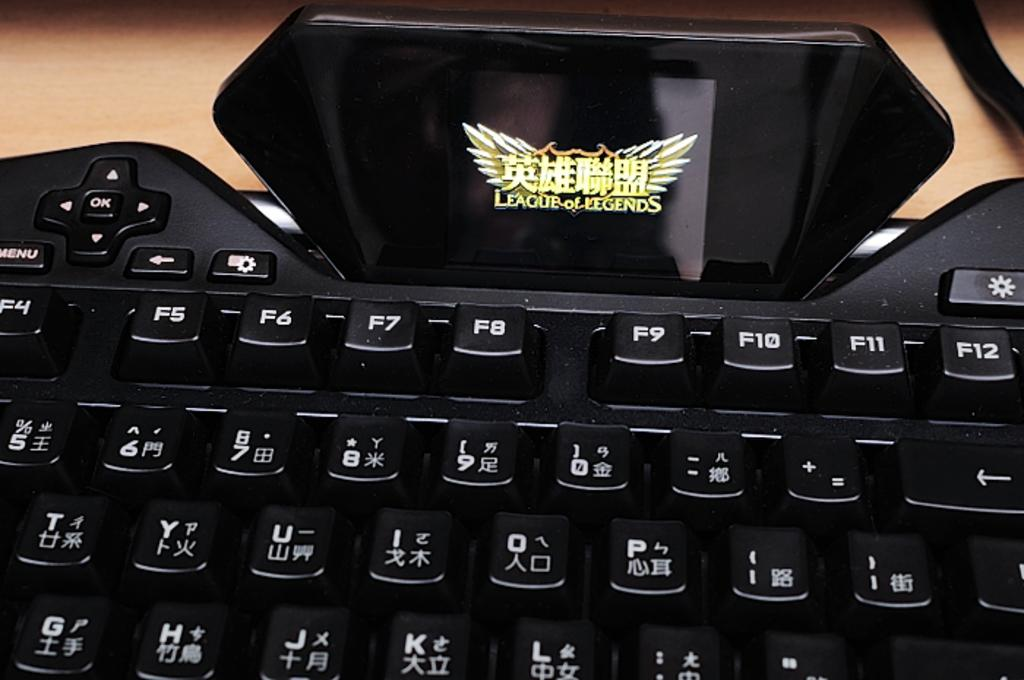<image>
Describe the image concisely. A black computer keyboard with League of Legends sticker at the top. 